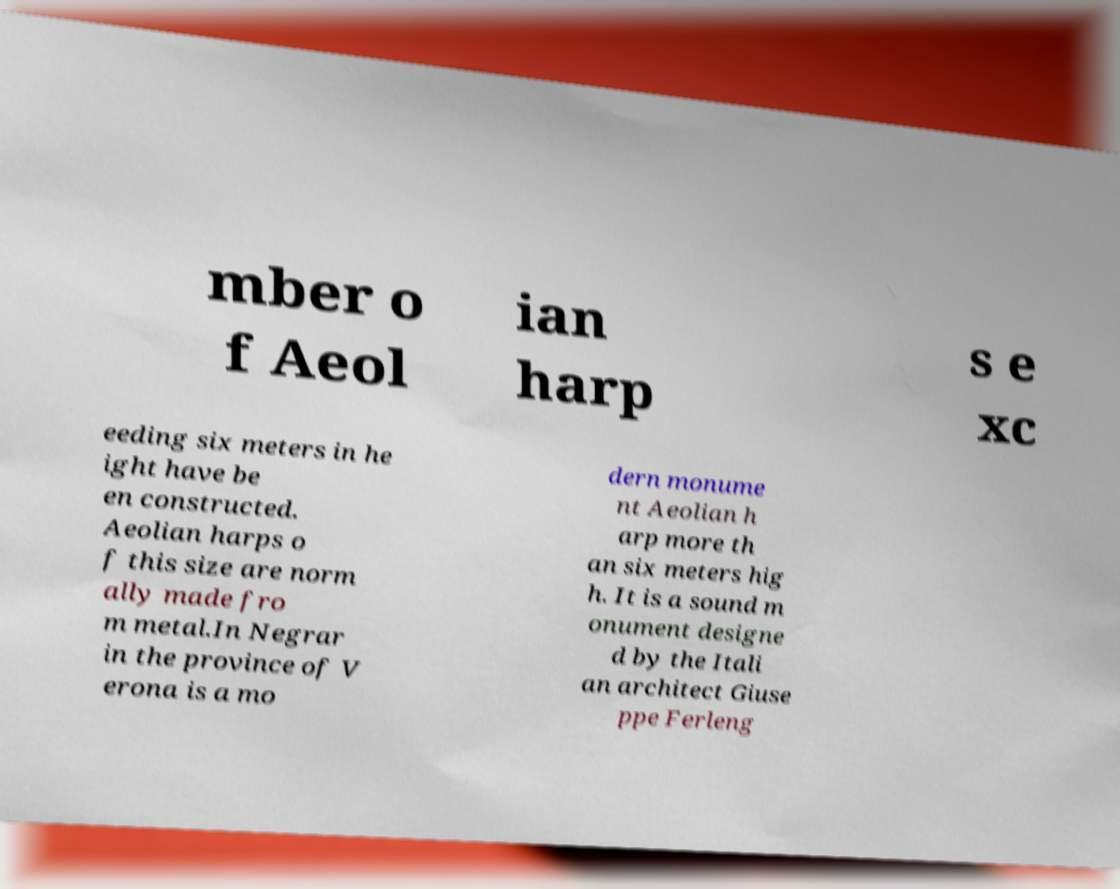Could you assist in decoding the text presented in this image and type it out clearly? mber o f Aeol ian harp s e xc eeding six meters in he ight have be en constructed. Aeolian harps o f this size are norm ally made fro m metal.In Negrar in the province of V erona is a mo dern monume nt Aeolian h arp more th an six meters hig h. It is a sound m onument designe d by the Itali an architect Giuse ppe Ferleng 